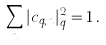<formula> <loc_0><loc_0><loc_500><loc_500>\sum _ { n } | c _ { q , n } | ^ { 2 } _ { q } = 1 \, .</formula> 